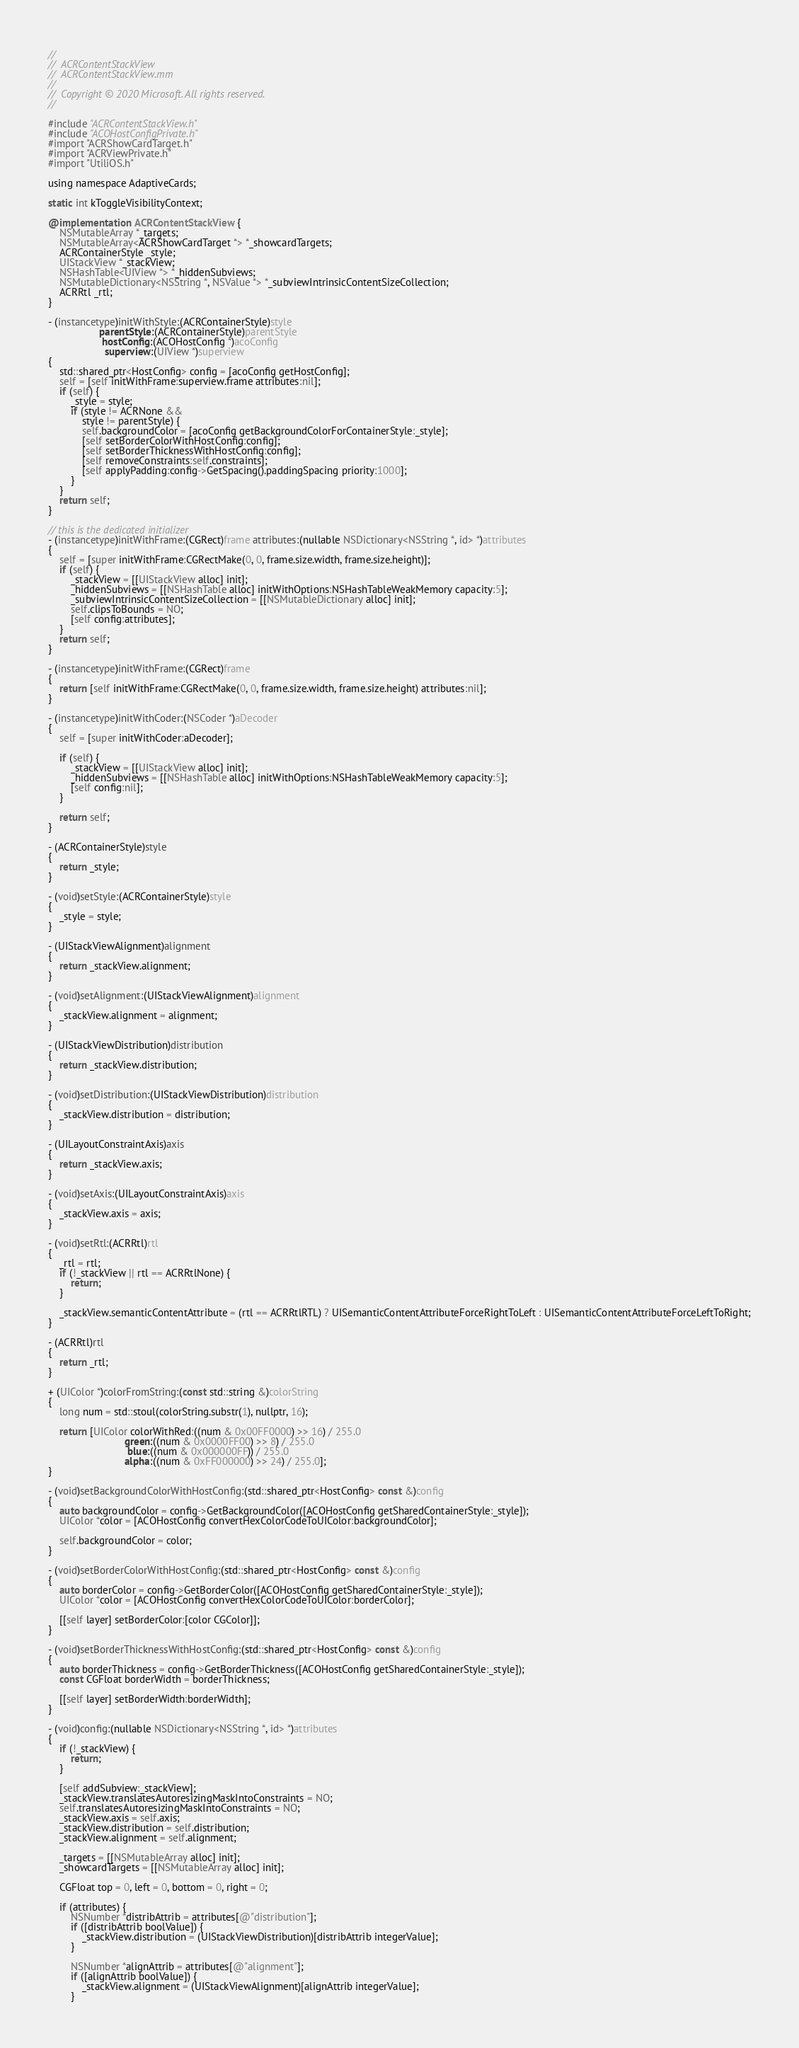Convert code to text. <code><loc_0><loc_0><loc_500><loc_500><_ObjectiveC_>//
//  ACRContentStackView
//  ACRContentStackView.mm
//
//  Copyright © 2020 Microsoft. All rights reserved.
//

#include "ACRContentStackView.h"
#include "ACOHostConfigPrivate.h"
#import "ACRShowCardTarget.h"
#import "ACRViewPrivate.h"
#import "UtiliOS.h"

using namespace AdaptiveCards;

static int kToggleVisibilityContext;

@implementation ACRContentStackView {
    NSMutableArray *_targets;
    NSMutableArray<ACRShowCardTarget *> *_showcardTargets;
    ACRContainerStyle _style;
    UIStackView *_stackView;
    NSHashTable<UIView *> *_hiddenSubviews;
    NSMutableDictionary<NSString *, NSValue *> *_subviewIntrinsicContentSizeCollection;
    ACRRtl _rtl;
}

- (instancetype)initWithStyle:(ACRContainerStyle)style
                  parentStyle:(ACRContainerStyle)parentStyle
                   hostConfig:(ACOHostConfig *)acoConfig
                    superview:(UIView *)superview
{
    std::shared_ptr<HostConfig> config = [acoConfig getHostConfig];
    self = [self initWithFrame:superview.frame attributes:nil];
    if (self) {
        _style = style;
        if (style != ACRNone &&
            style != parentStyle) {
            self.backgroundColor = [acoConfig getBackgroundColorForContainerStyle:_style];
            [self setBorderColorWithHostConfig:config];
            [self setBorderThicknessWithHostConfig:config];
            [self removeConstraints:self.constraints];
            [self applyPadding:config->GetSpacing().paddingSpacing priority:1000];
        }
    }
    return self;
}

// this is the dedicated initializer
- (instancetype)initWithFrame:(CGRect)frame attributes:(nullable NSDictionary<NSString *, id> *)attributes
{
    self = [super initWithFrame:CGRectMake(0, 0, frame.size.width, frame.size.height)];
    if (self) {
        _stackView = [[UIStackView alloc] init];
        _hiddenSubviews = [[NSHashTable alloc] initWithOptions:NSHashTableWeakMemory capacity:5];
        _subviewIntrinsicContentSizeCollection = [[NSMutableDictionary alloc] init];
        self.clipsToBounds = NO;
        [self config:attributes];
    }
    return self;
}

- (instancetype)initWithFrame:(CGRect)frame
{
    return [self initWithFrame:CGRectMake(0, 0, frame.size.width, frame.size.height) attributes:nil];
}

- (instancetype)initWithCoder:(NSCoder *)aDecoder
{
    self = [super initWithCoder:aDecoder];

    if (self) {
        _stackView = [[UIStackView alloc] init];
        _hiddenSubviews = [[NSHashTable alloc] initWithOptions:NSHashTableWeakMemory capacity:5];
        [self config:nil];
    }

    return self;
}

- (ACRContainerStyle)style
{
    return _style;
}

- (void)setStyle:(ACRContainerStyle)style
{
    _style = style;
}

- (UIStackViewAlignment)alignment
{
    return _stackView.alignment;
}

- (void)setAlignment:(UIStackViewAlignment)alignment
{
    _stackView.alignment = alignment;
}

- (UIStackViewDistribution)distribution
{
    return _stackView.distribution;
}

- (void)setDistribution:(UIStackViewDistribution)distribution
{
    _stackView.distribution = distribution;
}

- (UILayoutConstraintAxis)axis
{
    return _stackView.axis;
}

- (void)setAxis:(UILayoutConstraintAxis)axis
{
    _stackView.axis = axis;
}

- (void)setRtl:(ACRRtl)rtl
{
    _rtl = rtl;
    if (!_stackView || rtl == ACRRtlNone) {
        return;
    }

    _stackView.semanticContentAttribute = (rtl == ACRRtlRTL) ? UISemanticContentAttributeForceRightToLeft : UISemanticContentAttributeForceLeftToRight;
}

- (ACRRtl)rtl
{
    return _rtl;
}

+ (UIColor *)colorFromString:(const std::string &)colorString
{
    long num = std::stoul(colorString.substr(1), nullptr, 16);

    return [UIColor colorWithRed:((num & 0x00FF0000) >> 16) / 255.0
                           green:((num & 0x0000FF00) >> 8) / 255.0
                            blue:((num & 0x000000FF)) / 255.0
                           alpha:((num & 0xFF000000) >> 24) / 255.0];
}

- (void)setBackgroundColorWithHostConfig:(std::shared_ptr<HostConfig> const &)config
{
    auto backgroundColor = config->GetBackgroundColor([ACOHostConfig getSharedContainerStyle:_style]);
    UIColor *color = [ACOHostConfig convertHexColorCodeToUIColor:backgroundColor];

    self.backgroundColor = color;
}

- (void)setBorderColorWithHostConfig:(std::shared_ptr<HostConfig> const &)config
{
    auto borderColor = config->GetBorderColor([ACOHostConfig getSharedContainerStyle:_style]);
    UIColor *color = [ACOHostConfig convertHexColorCodeToUIColor:borderColor];

    [[self layer] setBorderColor:[color CGColor]];
}

- (void)setBorderThicknessWithHostConfig:(std::shared_ptr<HostConfig> const &)config
{
    auto borderThickness = config->GetBorderThickness([ACOHostConfig getSharedContainerStyle:_style]);
    const CGFloat borderWidth = borderThickness;

    [[self layer] setBorderWidth:borderWidth];
}

- (void)config:(nullable NSDictionary<NSString *, id> *)attributes
{
    if (!_stackView) {
        return;
    }

    [self addSubview:_stackView];
    _stackView.translatesAutoresizingMaskIntoConstraints = NO;
    self.translatesAutoresizingMaskIntoConstraints = NO;
    _stackView.axis = self.axis;
    _stackView.distribution = self.distribution;
    _stackView.alignment = self.alignment;

    _targets = [[NSMutableArray alloc] init];
    _showcardTargets = [[NSMutableArray alloc] init];

    CGFloat top = 0, left = 0, bottom = 0, right = 0;

    if (attributes) {
        NSNumber *distribAttrib = attributes[@"distribution"];
        if ([distribAttrib boolValue]) {
            _stackView.distribution = (UIStackViewDistribution)[distribAttrib integerValue];
        }

        NSNumber *alignAttrib = attributes[@"alignment"];
        if ([alignAttrib boolValue]) {
            _stackView.alignment = (UIStackViewAlignment)[alignAttrib integerValue];
        }
</code> 